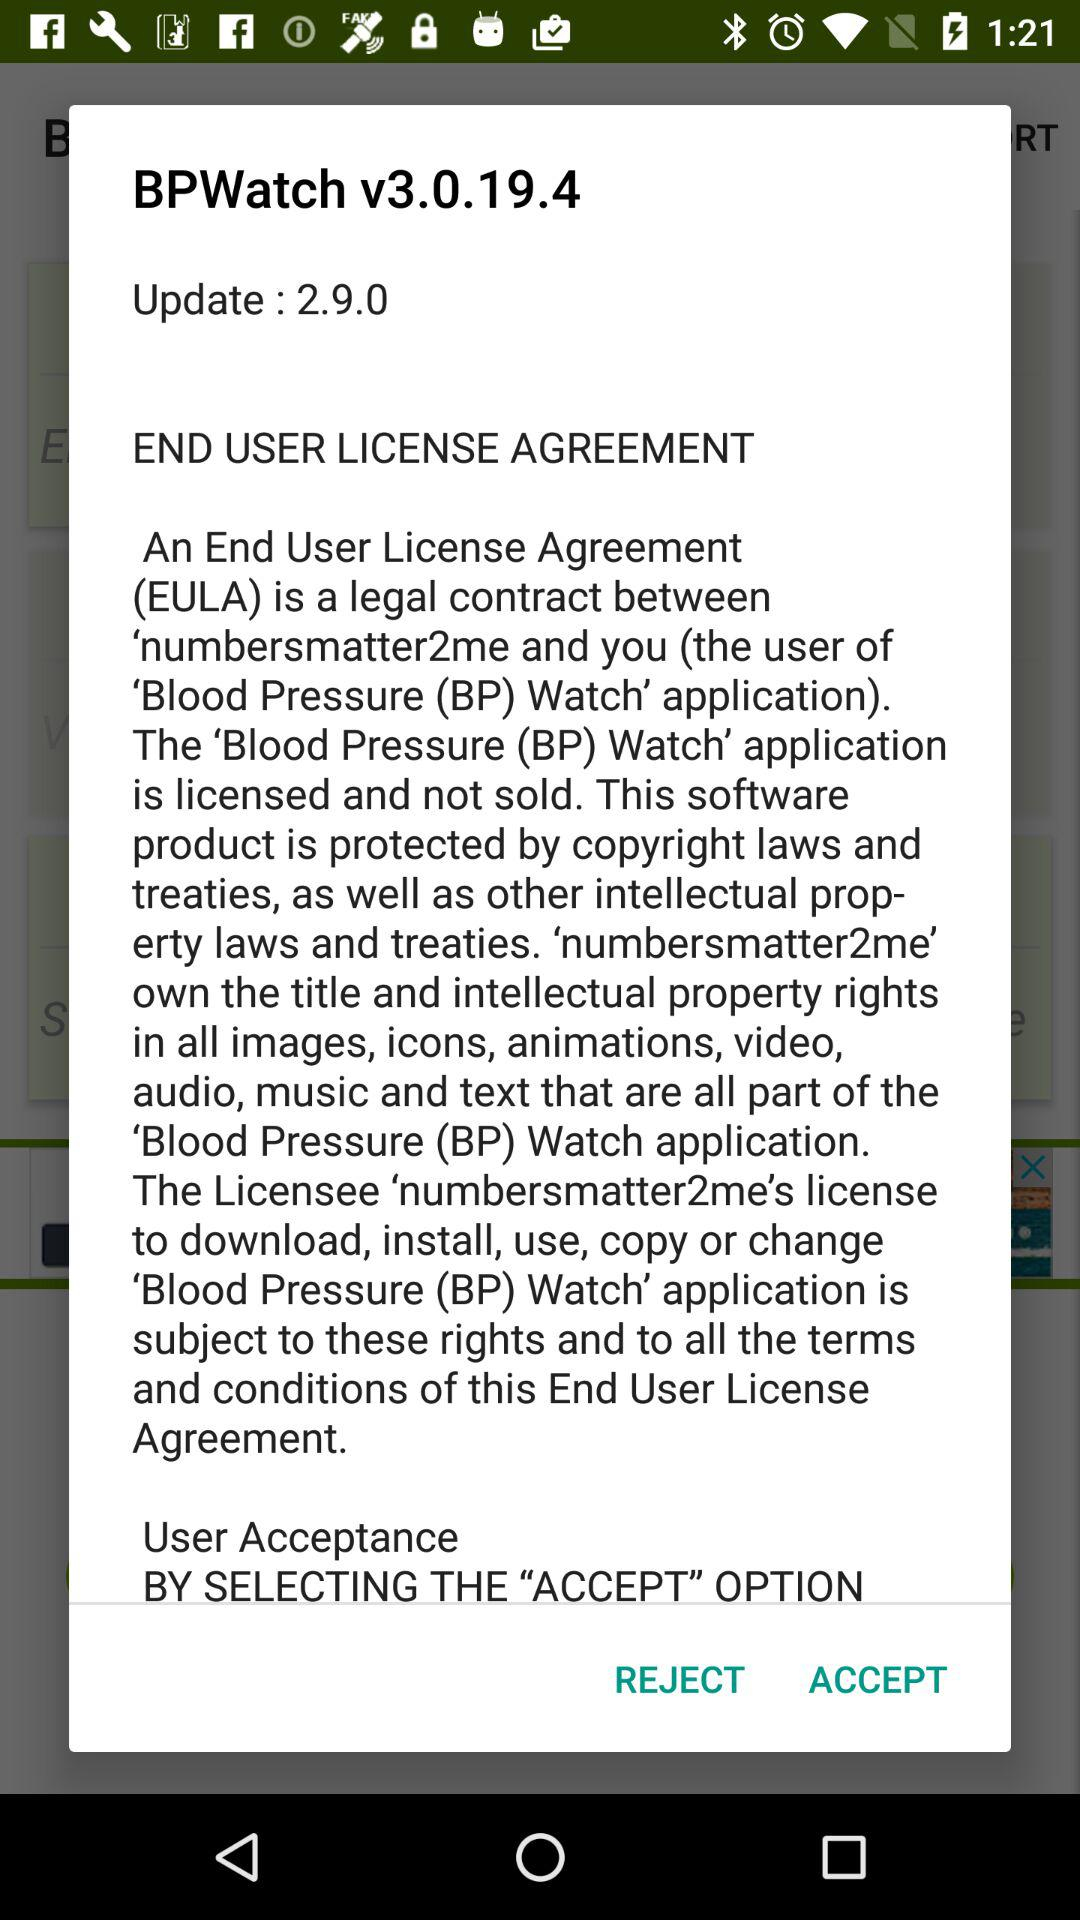What is the full form of BP? The full form of BP is Blood Pressure. 